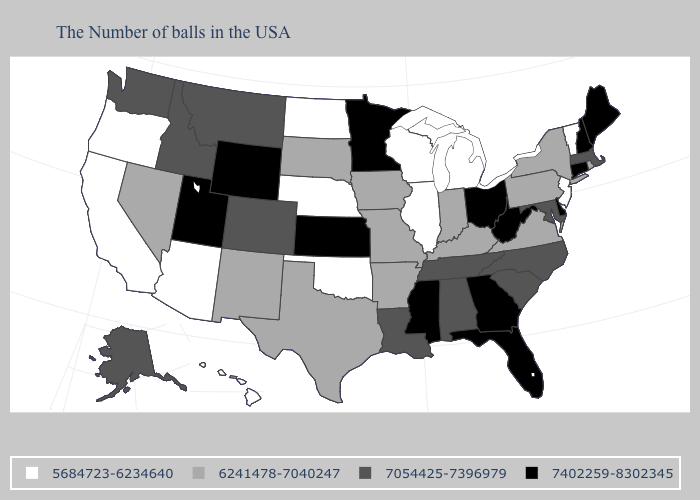Among the states that border Delaware , which have the lowest value?
Concise answer only. New Jersey. Name the states that have a value in the range 7402259-8302345?
Keep it brief. Maine, New Hampshire, Connecticut, Delaware, West Virginia, Ohio, Florida, Georgia, Mississippi, Minnesota, Kansas, Wyoming, Utah. Name the states that have a value in the range 5684723-6234640?
Write a very short answer. Vermont, New Jersey, Michigan, Wisconsin, Illinois, Nebraska, Oklahoma, North Dakota, Arizona, California, Oregon, Hawaii. What is the value of North Dakota?
Concise answer only. 5684723-6234640. Among the states that border Arkansas , which have the lowest value?
Short answer required. Oklahoma. Name the states that have a value in the range 7054425-7396979?
Quick response, please. Massachusetts, Maryland, North Carolina, South Carolina, Alabama, Tennessee, Louisiana, Colorado, Montana, Idaho, Washington, Alaska. Does Utah have a higher value than Hawaii?
Quick response, please. Yes. What is the value of Alaska?
Short answer required. 7054425-7396979. Among the states that border South Carolina , which have the highest value?
Write a very short answer. Georgia. What is the lowest value in the USA?
Give a very brief answer. 5684723-6234640. Does the first symbol in the legend represent the smallest category?
Write a very short answer. Yes. What is the value of New Jersey?
Be succinct. 5684723-6234640. What is the highest value in the Northeast ?
Quick response, please. 7402259-8302345. What is the lowest value in states that border Massachusetts?
Quick response, please. 5684723-6234640. Is the legend a continuous bar?
Give a very brief answer. No. 